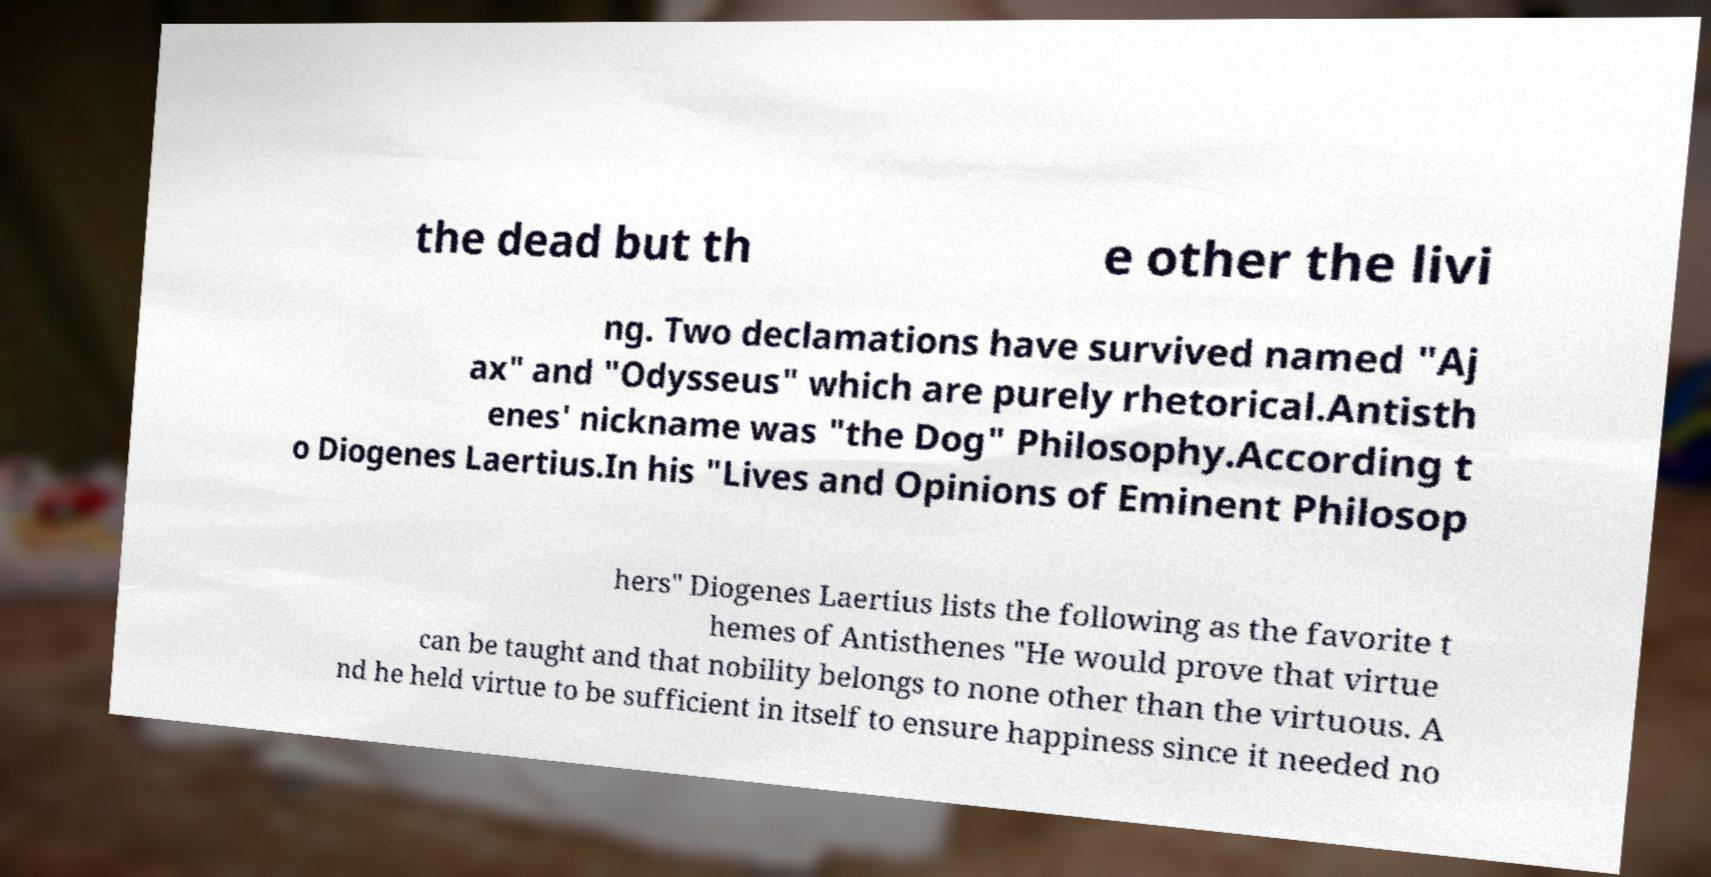Please identify and transcribe the text found in this image. the dead but th e other the livi ng. Two declamations have survived named "Aj ax" and "Odysseus" which are purely rhetorical.Antisth enes' nickname was "the Dog" Philosophy.According t o Diogenes Laertius.In his "Lives and Opinions of Eminent Philosop hers" Diogenes Laertius lists the following as the favorite t hemes of Antisthenes "He would prove that virtue can be taught and that nobility belongs to none other than the virtuous. A nd he held virtue to be sufficient in itself to ensure happiness since it needed no 